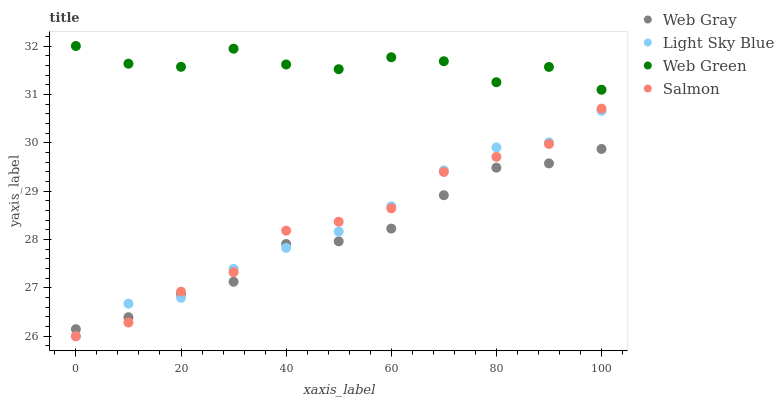Does Web Gray have the minimum area under the curve?
Answer yes or no. Yes. Does Web Green have the maximum area under the curve?
Answer yes or no. Yes. Does Salmon have the minimum area under the curve?
Answer yes or no. No. Does Salmon have the maximum area under the curve?
Answer yes or no. No. Is Light Sky Blue the smoothest?
Answer yes or no. Yes. Is Web Green the roughest?
Answer yes or no. Yes. Is Salmon the smoothest?
Answer yes or no. No. Is Salmon the roughest?
Answer yes or no. No. Does Salmon have the lowest value?
Answer yes or no. Yes. Does Web Green have the lowest value?
Answer yes or no. No. Does Web Green have the highest value?
Answer yes or no. Yes. Does Salmon have the highest value?
Answer yes or no. No. Is Light Sky Blue less than Web Green?
Answer yes or no. Yes. Is Web Green greater than Salmon?
Answer yes or no. Yes. Does Salmon intersect Web Gray?
Answer yes or no. Yes. Is Salmon less than Web Gray?
Answer yes or no. No. Is Salmon greater than Web Gray?
Answer yes or no. No. Does Light Sky Blue intersect Web Green?
Answer yes or no. No. 